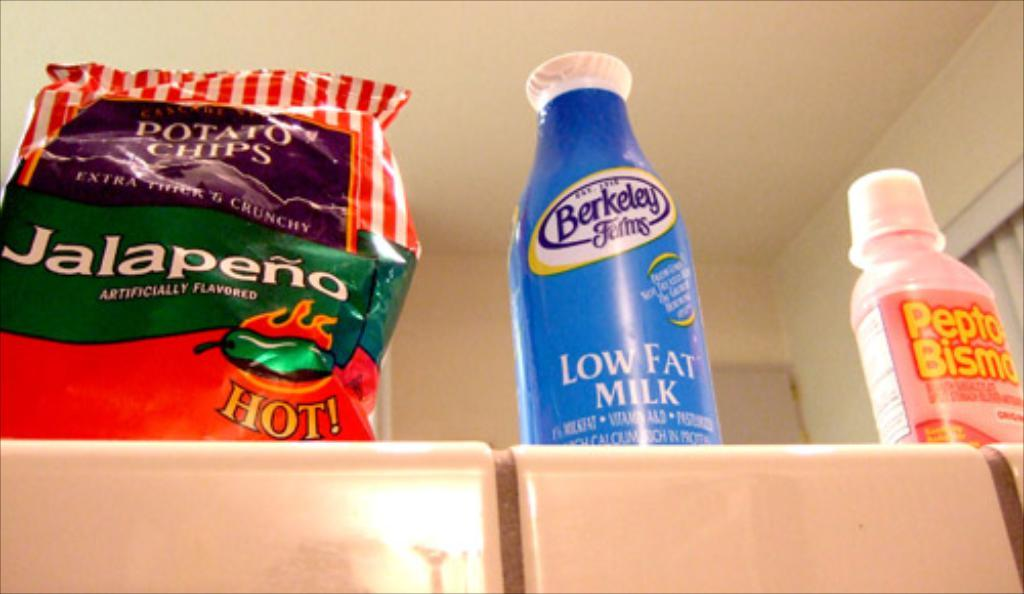Provide a one-sentence caption for the provided image. A bag of jalapeno potato chips sits next to a bottle of milk. 